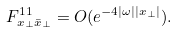<formula> <loc_0><loc_0><loc_500><loc_500>F _ { x _ { \perp } \bar { x } _ { \perp } } ^ { 1 1 } = O ( e ^ { - 4 | \omega | | x _ { \perp } | } ) .</formula> 